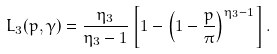<formula> <loc_0><loc_0><loc_500><loc_500>L _ { 3 } ( p , \gamma ) = \frac { \eta _ { 3 } } { \eta _ { 3 } - 1 } \left [ 1 - \left ( 1 - \frac { p } { \pi } \right ) ^ { \eta _ { 3 } - 1 } \right ] .</formula> 